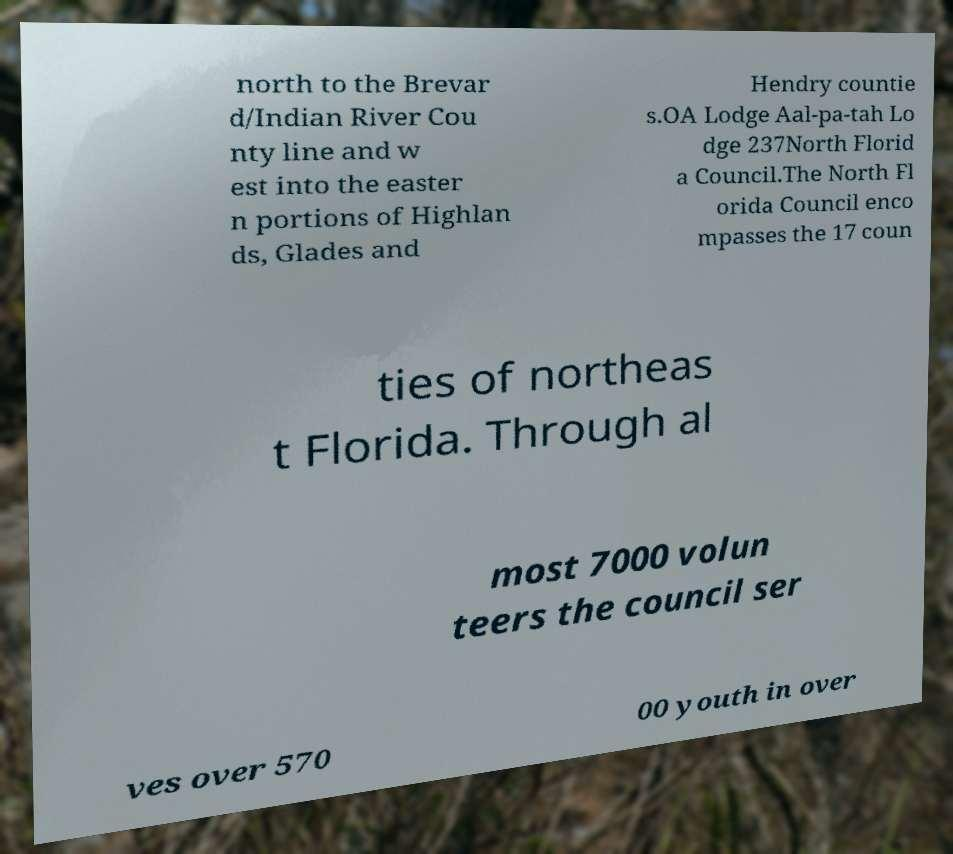There's text embedded in this image that I need extracted. Can you transcribe it verbatim? north to the Brevar d/Indian River Cou nty line and w est into the easter n portions of Highlan ds, Glades and Hendry countie s.OA Lodge Aal-pa-tah Lo dge 237North Florid a Council.The North Fl orida Council enco mpasses the 17 coun ties of northeas t Florida. Through al most 7000 volun teers the council ser ves over 570 00 youth in over 